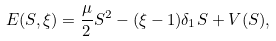<formula> <loc_0><loc_0><loc_500><loc_500>E ( S , \xi ) = \frac { \mu } { 2 } S ^ { 2 } - ( \xi - 1 ) \delta _ { 1 } S + V ( S ) ,</formula> 